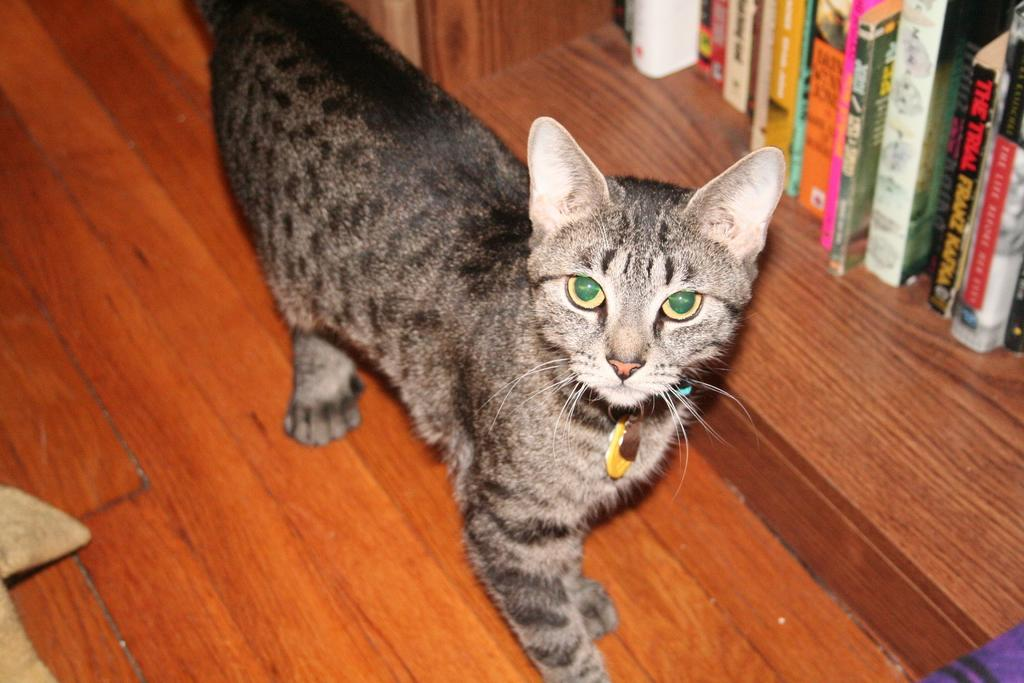What type of animal is in the image? There is a cat in the image. Where are the books located in the image? The books are in the top right of the image. What type of flag is being waved by the cat in the image? There is no flag present in the image, and the cat is not waving anything. 